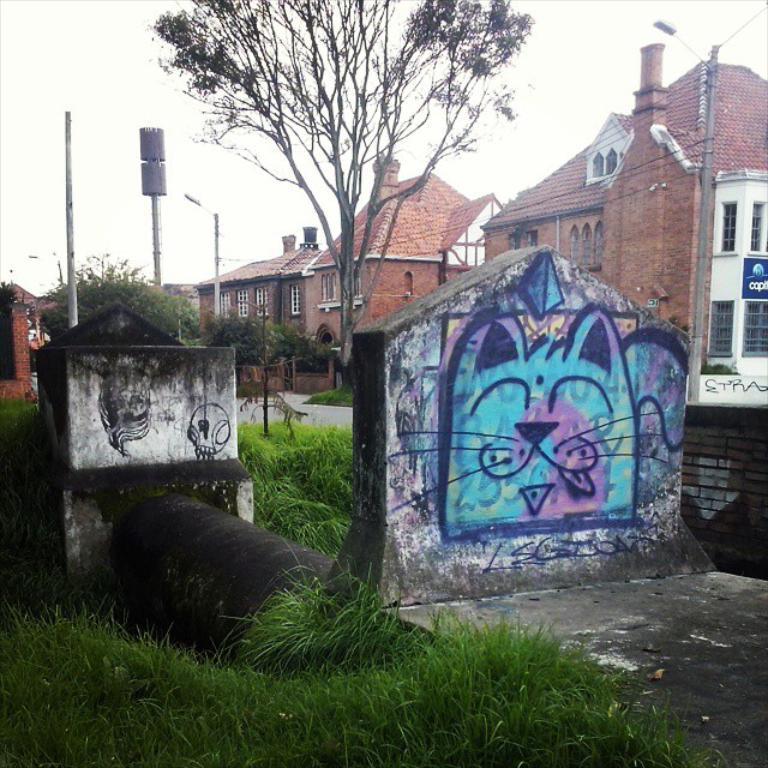Please provide a concise description of this image. At the bottom of the image there is grass on the ground. And also there is a pipe with walls and on the walls there is graffiti. In the background there are poles with lights and wires. And also there are trees and buildings with walls, windows, roofs and chimneys. At the top of the image there is sky. 